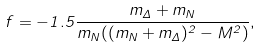<formula> <loc_0><loc_0><loc_500><loc_500>f = - 1 . 5 \frac { m _ { \Delta } + m _ { N } } { m _ { N } ( ( m _ { N } + m _ { \Delta } ) ^ { 2 } - M ^ { 2 } ) } ,</formula> 